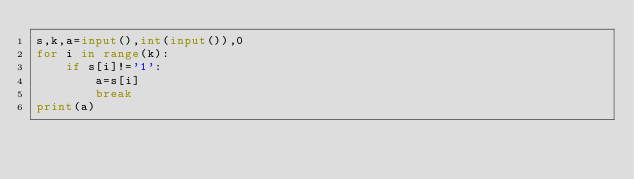Convert code to text. <code><loc_0><loc_0><loc_500><loc_500><_Python_>s,k,a=input(),int(input()),0
for i in range(k):
    if s[i]!='1':
        a=s[i]
        break
print(a)</code> 